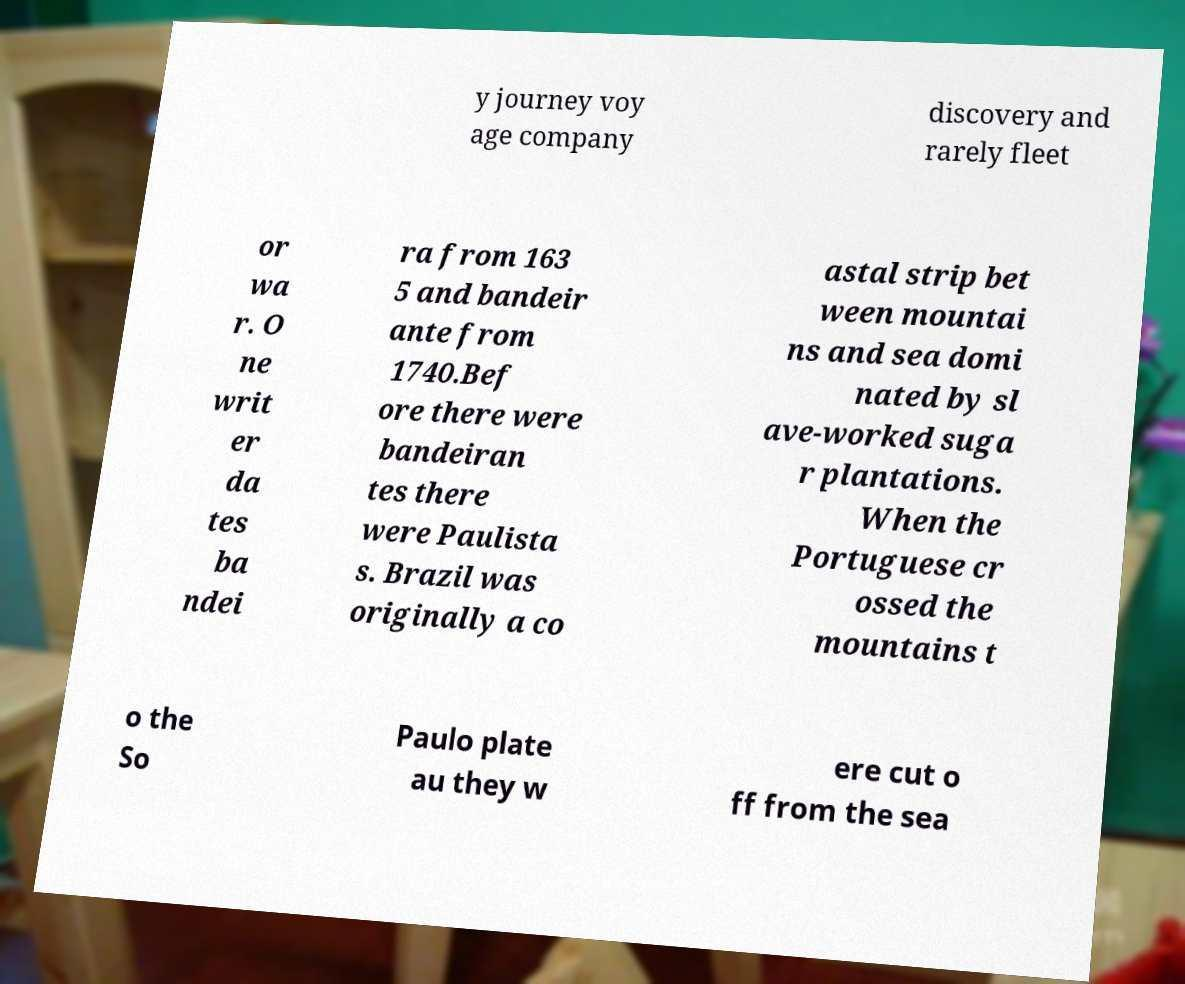Please identify and transcribe the text found in this image. y journey voy age company discovery and rarely fleet or wa r. O ne writ er da tes ba ndei ra from 163 5 and bandeir ante from 1740.Bef ore there were bandeiran tes there were Paulista s. Brazil was originally a co astal strip bet ween mountai ns and sea domi nated by sl ave-worked suga r plantations. When the Portuguese cr ossed the mountains t o the So Paulo plate au they w ere cut o ff from the sea 